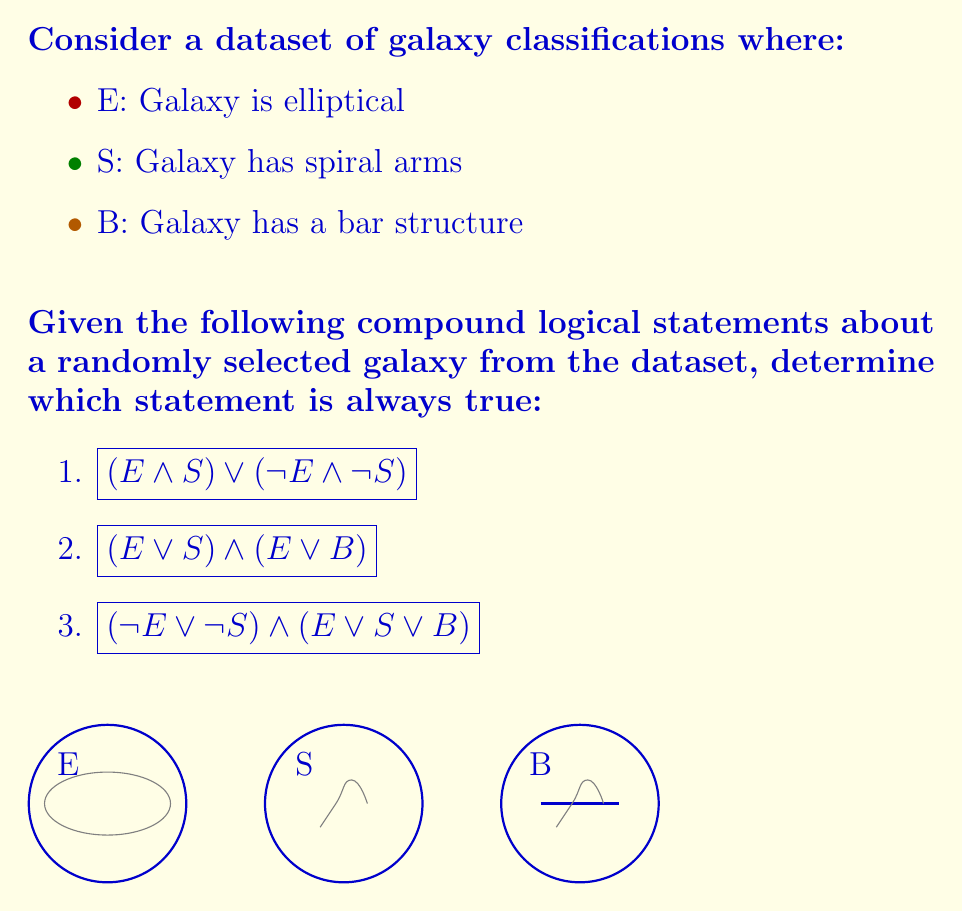Can you answer this question? Let's evaluate each statement:

1. $$(E \land S) \lor (\lnot E \land \lnot S)$$
   This statement is true when a galaxy is either both elliptical and spiral (which is impossible) or neither elliptical nor spiral. It's not always true because there are galaxies that are either elliptical or spiral.

2. $$(E \lor S) \land (E \lor B)$$
   This statement is true when a galaxy is either:
   - Elliptical (E)
   - Spiral and has a bar structure (S and B)
   - Spiral without a bar structure (S)
   It's not always true because there could be galaxies that are neither elliptical nor spiral, and don't have a bar structure.

3. $$(\lnot E \lor \lnot S) \land (E \lor S \lor B)$$
   Let's break this down:
   - $(\lnot E \lor \lnot S)$ is true for all galaxies because a galaxy cannot be both elliptical and spiral simultaneously.
   - $(E \lor S \lor B)$ is true for all galaxies because every galaxy must be either elliptical, spiral, or have a bar structure (or a combination of these).
   
   Since both parts of this compound statement are always true, their conjunction is always true for any galaxy in the dataset.

Therefore, statement 3 is the only one that is always true for any randomly selected galaxy from the dataset.
Answer: Statement 3: $$(\lnot E \lor \lnot S) \land (E \lor S \lor B)$$ 